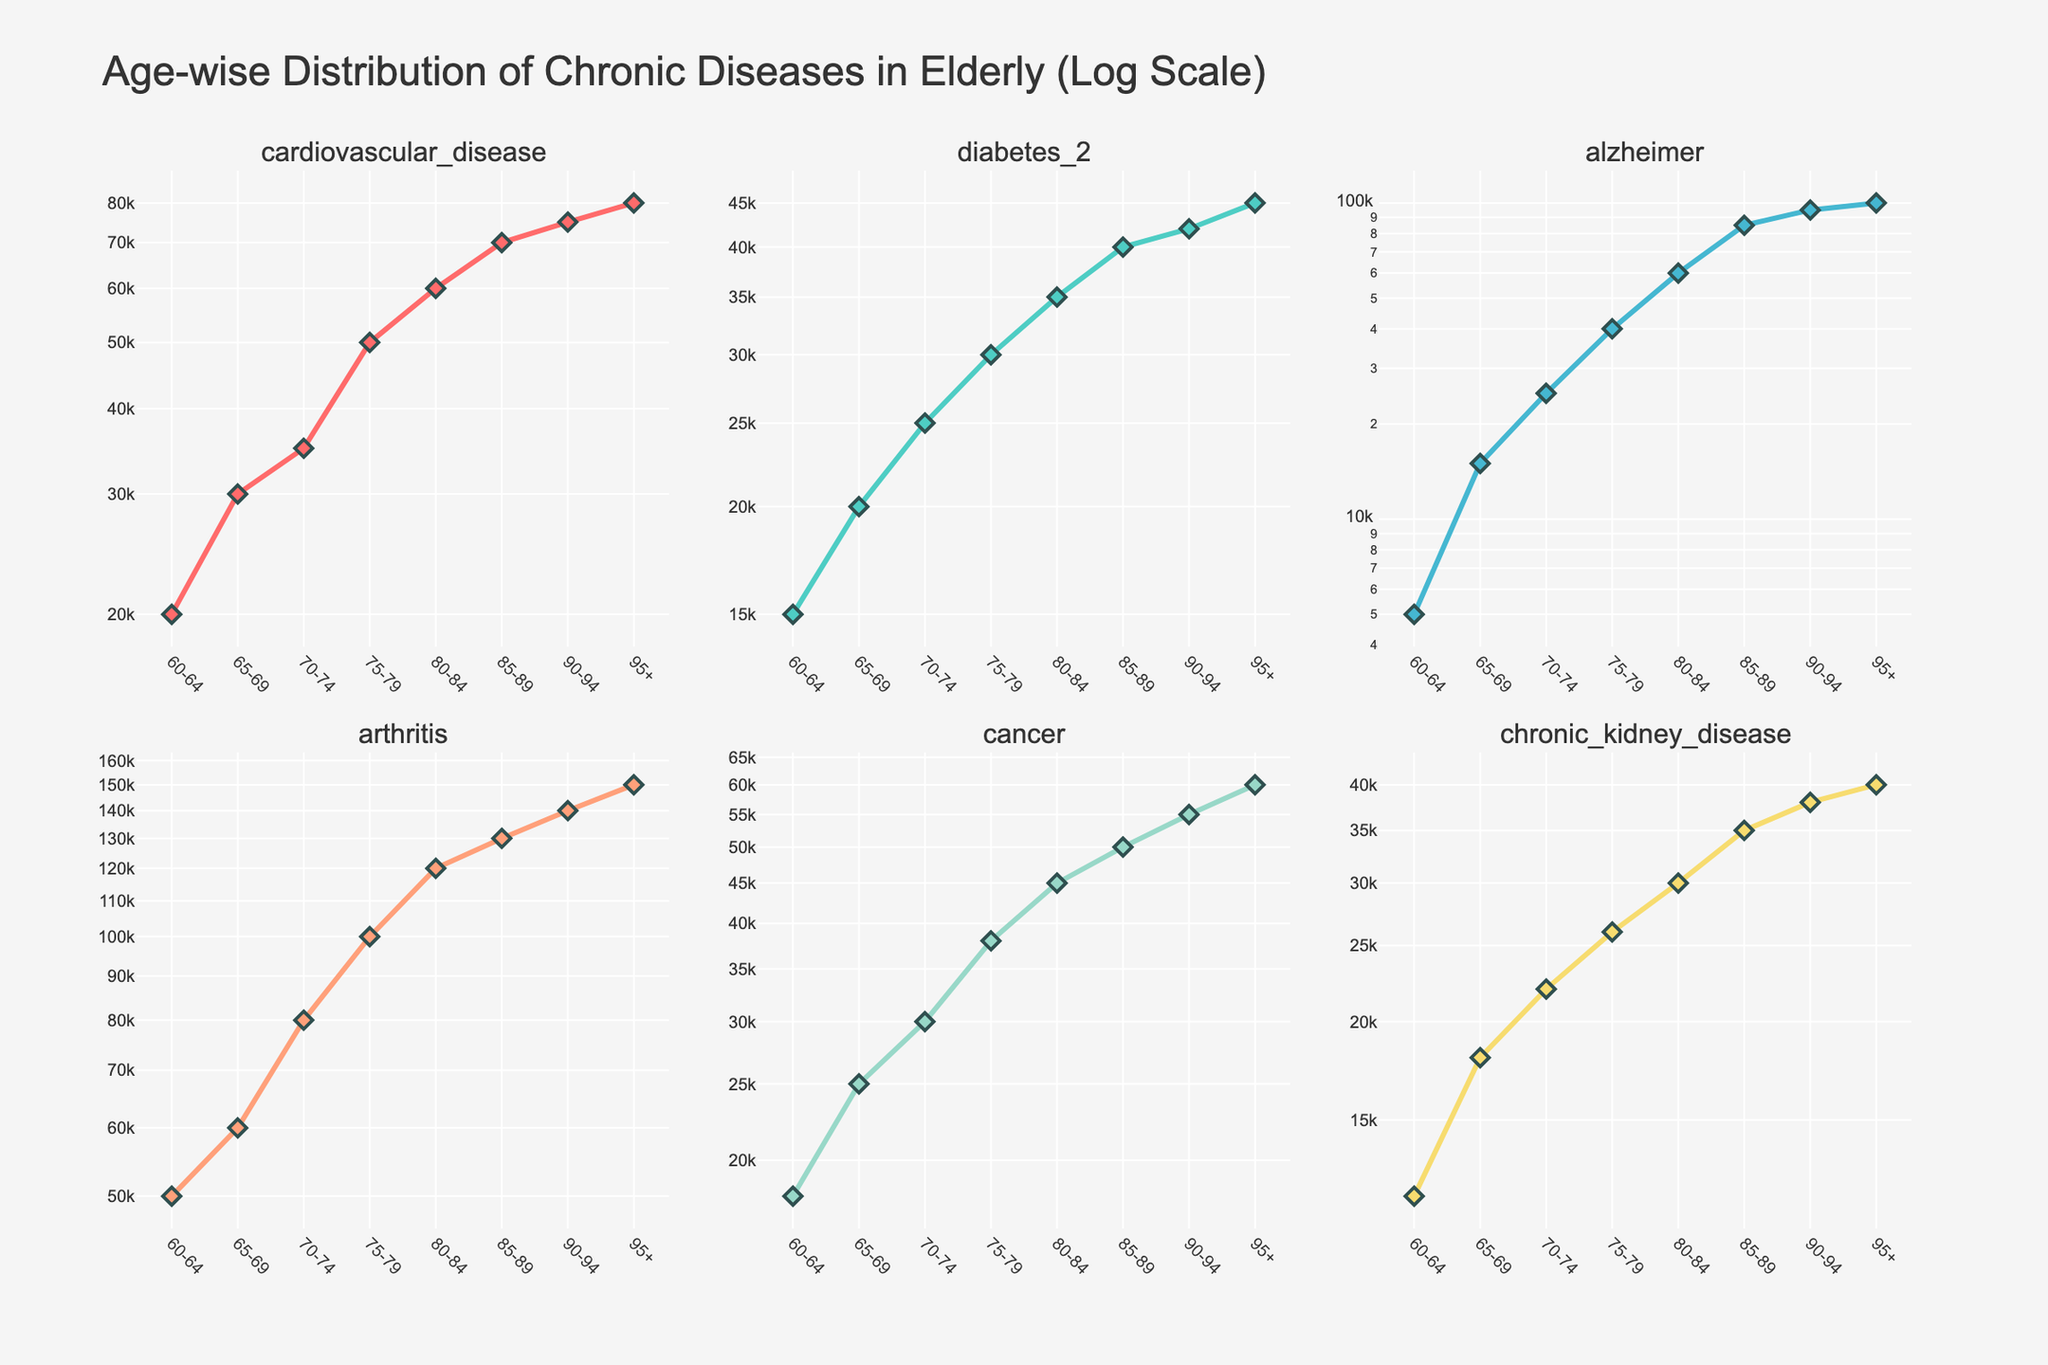What's the title of the figure? The title of the figure is displayed at the top of the plot.
Answer: Age-wise Distribution of Chronic Diseases in Elderly (Log Scale) How does the prevalence of cardiovascular disease compare across age groups? By examining the 'cardiovascular_disease' subplot, we observe that the number increases consistently across the age groups from 60-64 to 95+ on a log scale.
Answer: It consistently increases with age What age group has the highest number of Alzheimer cases? Looking at the 'alzheimer' subplot, the highest point on the y-axis corresponds to the age group '95+'.
Answer: 95+ Which disease shows the steepest increase in prevalence as age increases? By comparing the slopes of the lines in each subplot, the 'alzheimer' and 'arthritis' curves show steep increases, with 'alzheimer' standing out the most.
Answer: Alzheimer In which disease category do we see an increase in the number of cases from age group 60-64 to 65-69 but a stabilization in higher age groups? By examining the diabetes subplot, we see the case counts increase between 60-64 to 65-69 and further, but the rise is less sharp compared to other chronic diseases.
Answer: Diabetes 2 Do any diseases plateau or decrease in prevalence as age increases? Observing all subplots, none of the diseases show a plateau or decrease in prevalence; all continuously increase, mostly steeply.
Answer: No Which age group has the lowest number of Chronic Kidney Disease cases? Refer to the 'chronic_kidney_disease' subplot and identify the smallest value, which is for the age group '60-64'.
Answer: 60-64 What is the trend in the number of arthritis cases as age increases? In the 'arthritis' subplot, the data points and the trend line show a significant increase in the number of cases as age progresses from 60-64 to 95+.
Answer: Increasing By roughly how many cases does the prevalence of cancer increase from age group 70-74 to 80-84? We need to find the difference between the cancer cases at ages 80-84 (45,000) and 70-74 (30,000), which is a subtraction problem.
Answer: Approximately 15,000 Which disease shows a relatively uniform increase across age groups? By examining the consistent upward trendlines, 'chronic_kidney_disease' shows a relatively uniform increase.
Answer: Chronic Kidney Disease 